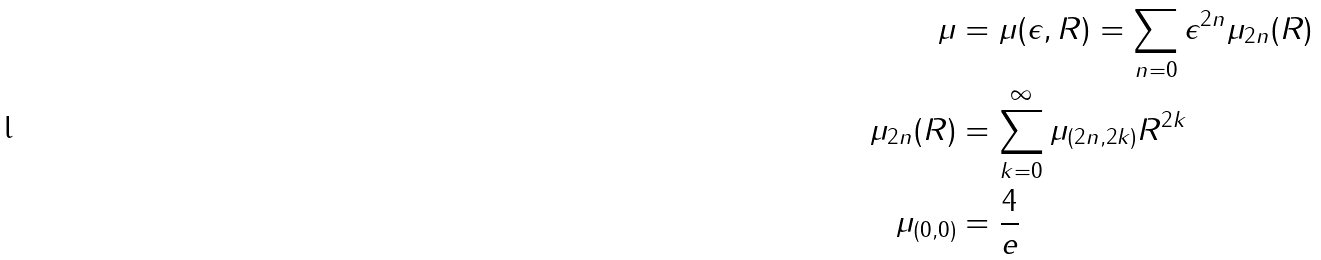<formula> <loc_0><loc_0><loc_500><loc_500>\mu & = \mu ( \epsilon , R ) = \sum _ { n = 0 } \epsilon ^ { 2 n } \mu _ { 2 n } ( R ) \\ \mu _ { 2 n } ( R ) & = \sum _ { k = 0 } ^ { \infty } \mu _ { ( 2 n , 2 k ) } R ^ { 2 k } \\ \mu _ { ( 0 , 0 ) } & = \frac { 4 } { e }</formula> 